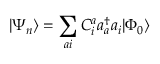Convert formula to latex. <formula><loc_0><loc_0><loc_500><loc_500>| \Psi _ { n } \rangle = \sum _ { a i } C _ { i } ^ { a } a _ { a } ^ { \dagger } a _ { i } | \Phi _ { 0 } \rangle</formula> 